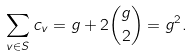Convert formula to latex. <formula><loc_0><loc_0><loc_500><loc_500>\sum _ { v \in S } c _ { v } = g + 2 \binom { g } { 2 } = g ^ { 2 } .</formula> 